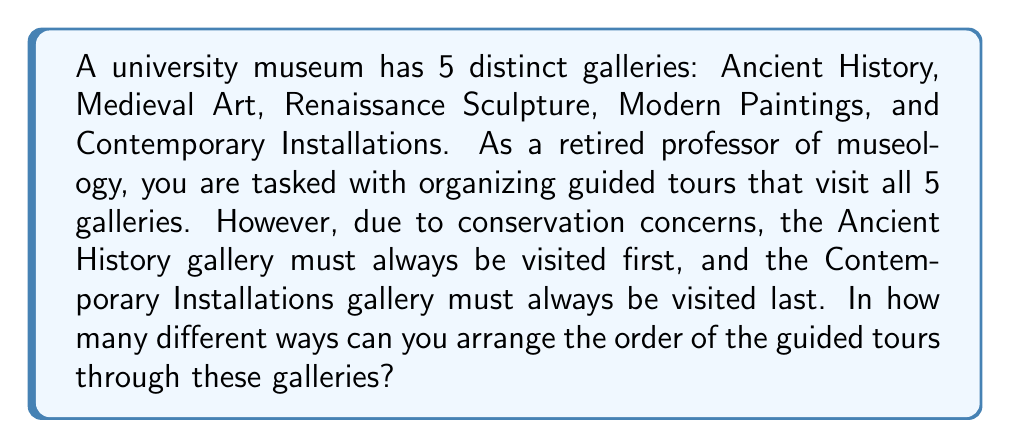Provide a solution to this math problem. Let's approach this step-by-step:

1) We know that the Ancient History gallery must be first and the Contemporary Installations gallery must be last. This means we only need to determine the order of the remaining 3 galleries.

2) This is a permutation problem. We need to find the number of ways to arrange 3 distinct objects (the remaining 3 galleries).

3) The formula for permutations of n distinct objects is:

   $$P(n) = n!$$

   Where n! (n factorial) is the product of all positive integers less than or equal to n.

4) In this case, n = 3, so we need to calculate 3!:

   $$3! = 3 \times 2 \times 1 = 6$$

5) Therefore, there are 6 different ways to arrange the order of the middle 3 galleries.

6) Since the first and last galleries are fixed, each of these 6 arrangements represents a unique tour order through all 5 galleries.

Thus, there are 6 different ways to organize the guided tours through the 5 galleries under the given constraints.
Answer: 6 